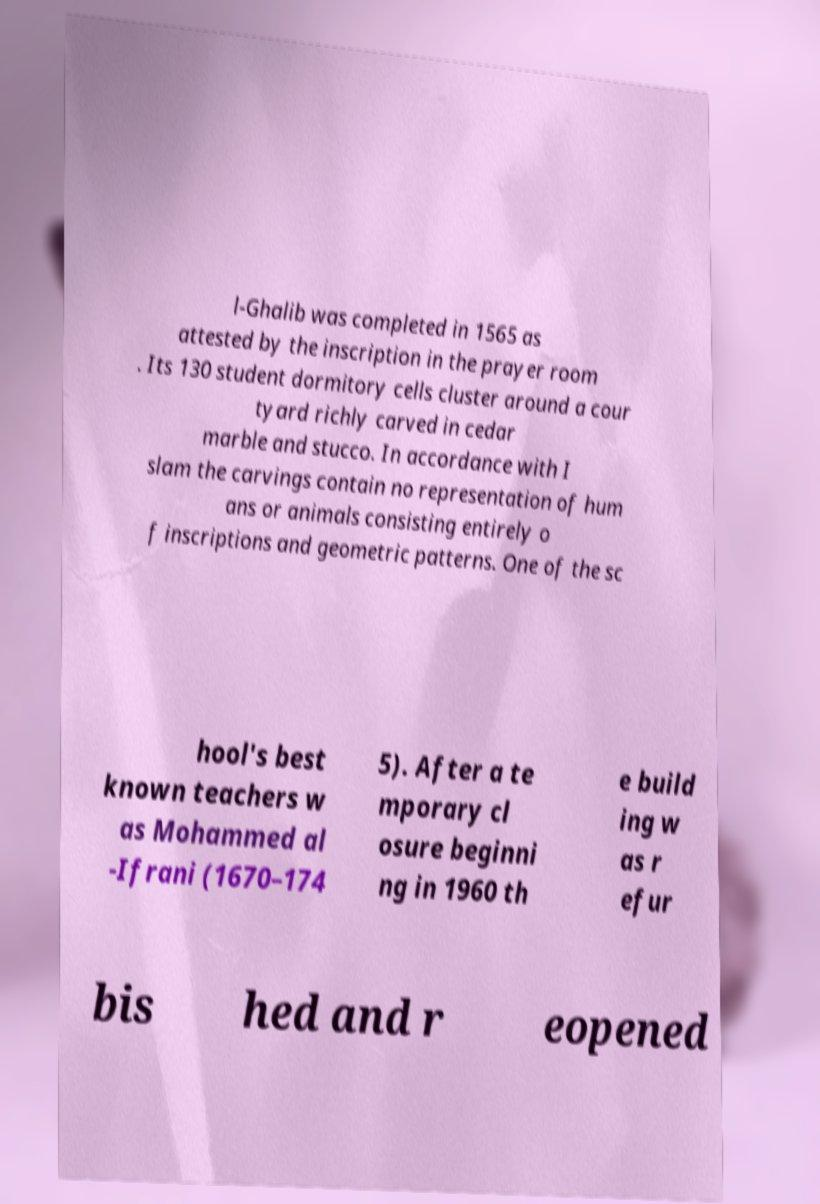Please read and relay the text visible in this image. What does it say? l-Ghalib was completed in 1565 as attested by the inscription in the prayer room . Its 130 student dormitory cells cluster around a cour tyard richly carved in cedar marble and stucco. In accordance with I slam the carvings contain no representation of hum ans or animals consisting entirely o f inscriptions and geometric patterns. One of the sc hool's best known teachers w as Mohammed al -Ifrani (1670–174 5). After a te mporary cl osure beginni ng in 1960 th e build ing w as r efur bis hed and r eopened 